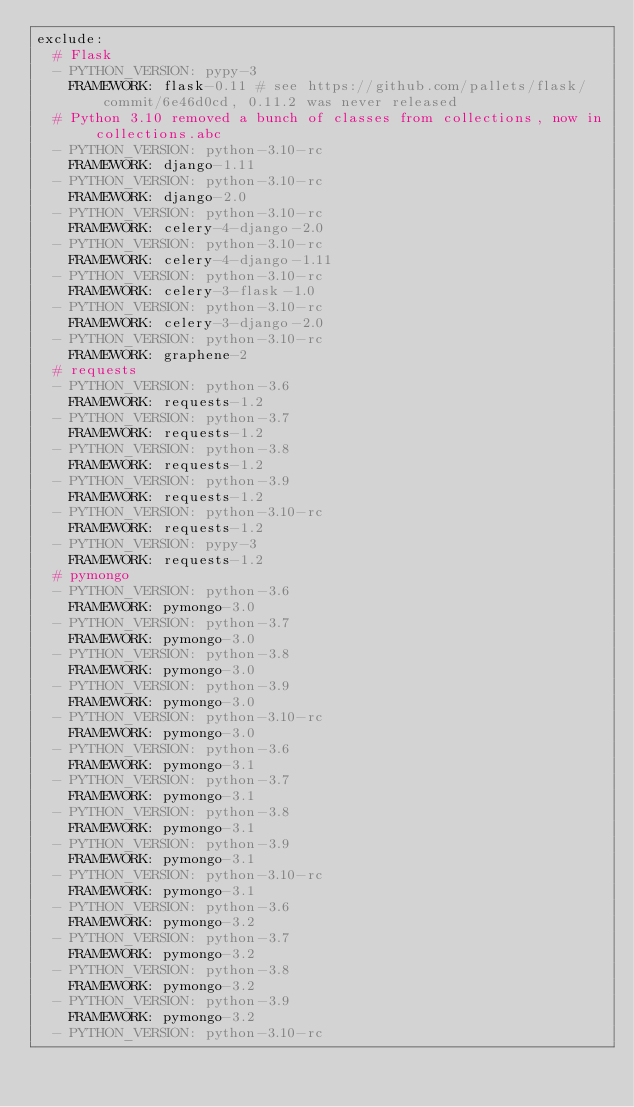<code> <loc_0><loc_0><loc_500><loc_500><_YAML_>exclude:
  # Flask
  - PYTHON_VERSION: pypy-3
    FRAMEWORK: flask-0.11 # see https://github.com/pallets/flask/commit/6e46d0cd, 0.11.2 was never released
  # Python 3.10 removed a bunch of classes from collections, now in collections.abc
  - PYTHON_VERSION: python-3.10-rc
    FRAMEWORK: django-1.11
  - PYTHON_VERSION: python-3.10-rc
    FRAMEWORK: django-2.0
  - PYTHON_VERSION: python-3.10-rc
    FRAMEWORK: celery-4-django-2.0
  - PYTHON_VERSION: python-3.10-rc
    FRAMEWORK: celery-4-django-1.11
  - PYTHON_VERSION: python-3.10-rc
    FRAMEWORK: celery-3-flask-1.0
  - PYTHON_VERSION: python-3.10-rc
    FRAMEWORK: celery-3-django-2.0
  - PYTHON_VERSION: python-3.10-rc
    FRAMEWORK: graphene-2
  # requests
  - PYTHON_VERSION: python-3.6
    FRAMEWORK: requests-1.2
  - PYTHON_VERSION: python-3.7
    FRAMEWORK: requests-1.2
  - PYTHON_VERSION: python-3.8
    FRAMEWORK: requests-1.2
  - PYTHON_VERSION: python-3.9
    FRAMEWORK: requests-1.2
  - PYTHON_VERSION: python-3.10-rc
    FRAMEWORK: requests-1.2
  - PYTHON_VERSION: pypy-3
    FRAMEWORK: requests-1.2
  # pymongo
  - PYTHON_VERSION: python-3.6
    FRAMEWORK: pymongo-3.0
  - PYTHON_VERSION: python-3.7
    FRAMEWORK: pymongo-3.0
  - PYTHON_VERSION: python-3.8
    FRAMEWORK: pymongo-3.0
  - PYTHON_VERSION: python-3.9
    FRAMEWORK: pymongo-3.0
  - PYTHON_VERSION: python-3.10-rc
    FRAMEWORK: pymongo-3.0
  - PYTHON_VERSION: python-3.6
    FRAMEWORK: pymongo-3.1
  - PYTHON_VERSION: python-3.7
    FRAMEWORK: pymongo-3.1
  - PYTHON_VERSION: python-3.8
    FRAMEWORK: pymongo-3.1
  - PYTHON_VERSION: python-3.9
    FRAMEWORK: pymongo-3.1
  - PYTHON_VERSION: python-3.10-rc
    FRAMEWORK: pymongo-3.1
  - PYTHON_VERSION: python-3.6
    FRAMEWORK: pymongo-3.2
  - PYTHON_VERSION: python-3.7
    FRAMEWORK: pymongo-3.2
  - PYTHON_VERSION: python-3.8
    FRAMEWORK: pymongo-3.2
  - PYTHON_VERSION: python-3.9
    FRAMEWORK: pymongo-3.2
  - PYTHON_VERSION: python-3.10-rc</code> 